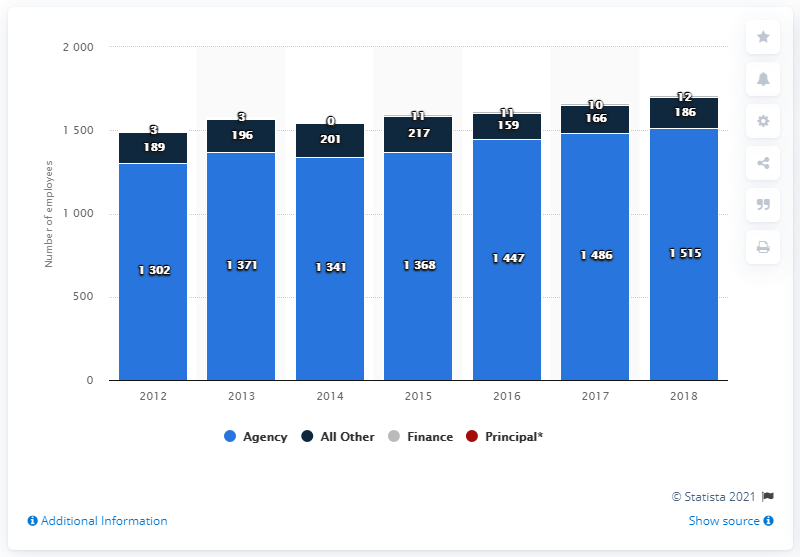Give some essential details in this illustration. The average number of employees at the agency is approximately 1404.286. In 2018, the agency had the highest number of employees compared to the previous years. 